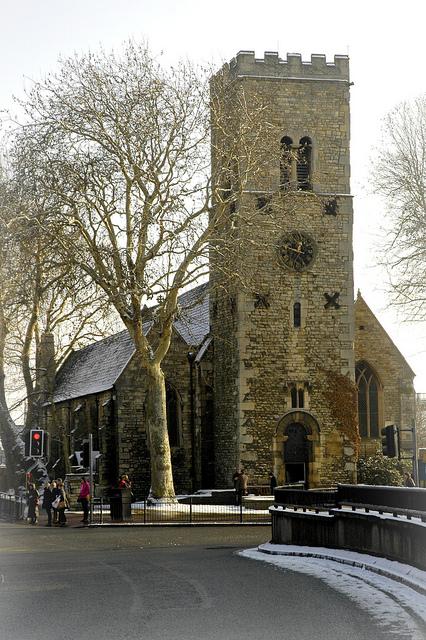Where is the clock?
Short answer required. On tower. How many people are there in the photo?
Give a very brief answer. 5. What is red?
Concise answer only. Light. 